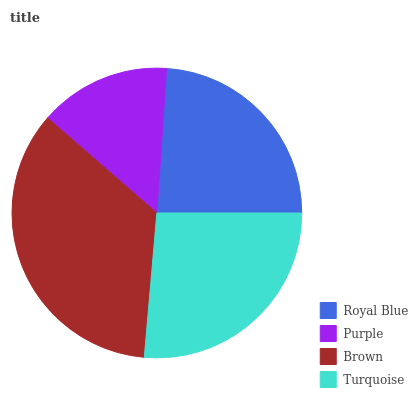Is Purple the minimum?
Answer yes or no. Yes. Is Brown the maximum?
Answer yes or no. Yes. Is Brown the minimum?
Answer yes or no. No. Is Purple the maximum?
Answer yes or no. No. Is Brown greater than Purple?
Answer yes or no. Yes. Is Purple less than Brown?
Answer yes or no. Yes. Is Purple greater than Brown?
Answer yes or no. No. Is Brown less than Purple?
Answer yes or no. No. Is Turquoise the high median?
Answer yes or no. Yes. Is Royal Blue the low median?
Answer yes or no. Yes. Is Royal Blue the high median?
Answer yes or no. No. Is Brown the low median?
Answer yes or no. No. 